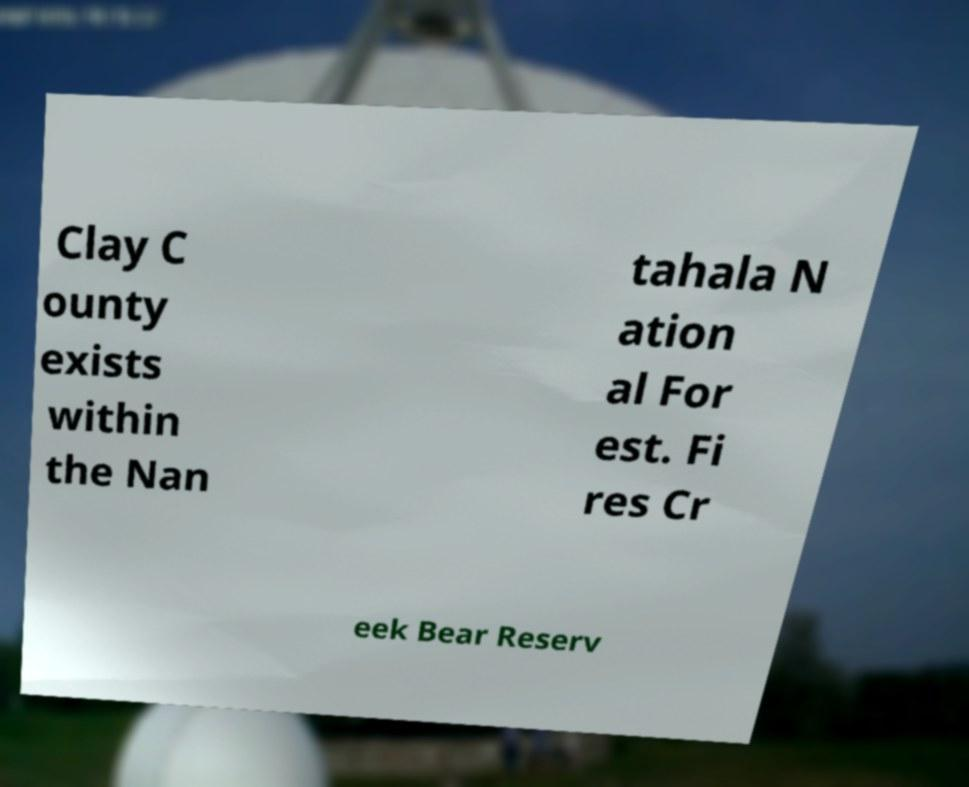For documentation purposes, I need the text within this image transcribed. Could you provide that? Clay C ounty exists within the Nan tahala N ation al For est. Fi res Cr eek Bear Reserv 